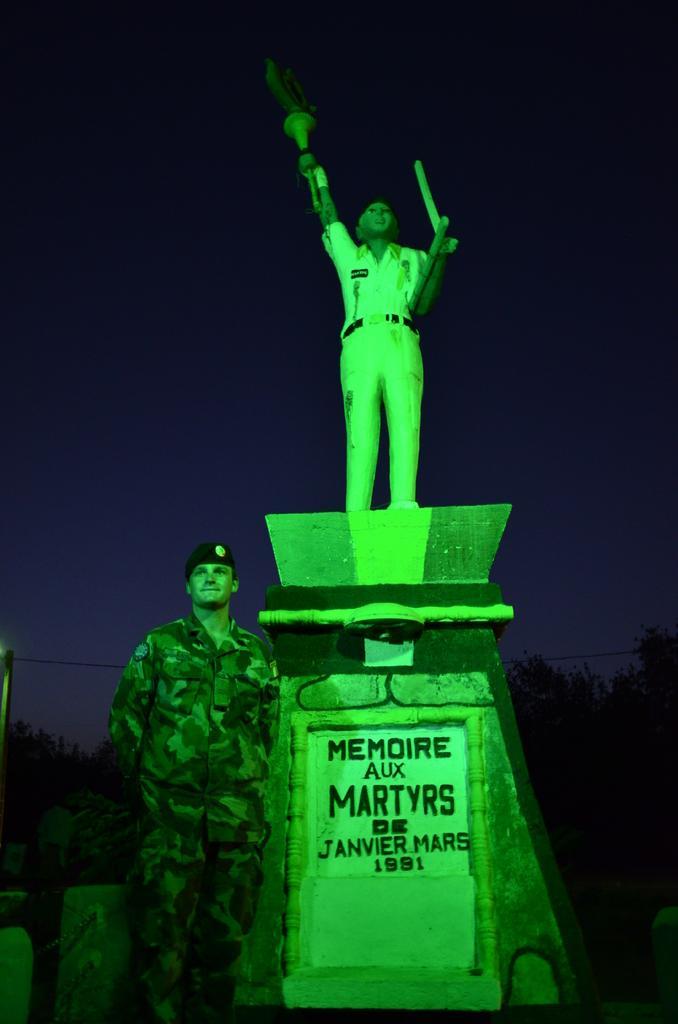Can you describe this image briefly? In this image there is a statue of a person holding some objects on the rock structure with some text on it, behind the statue there is a person standing. The background is dark. 